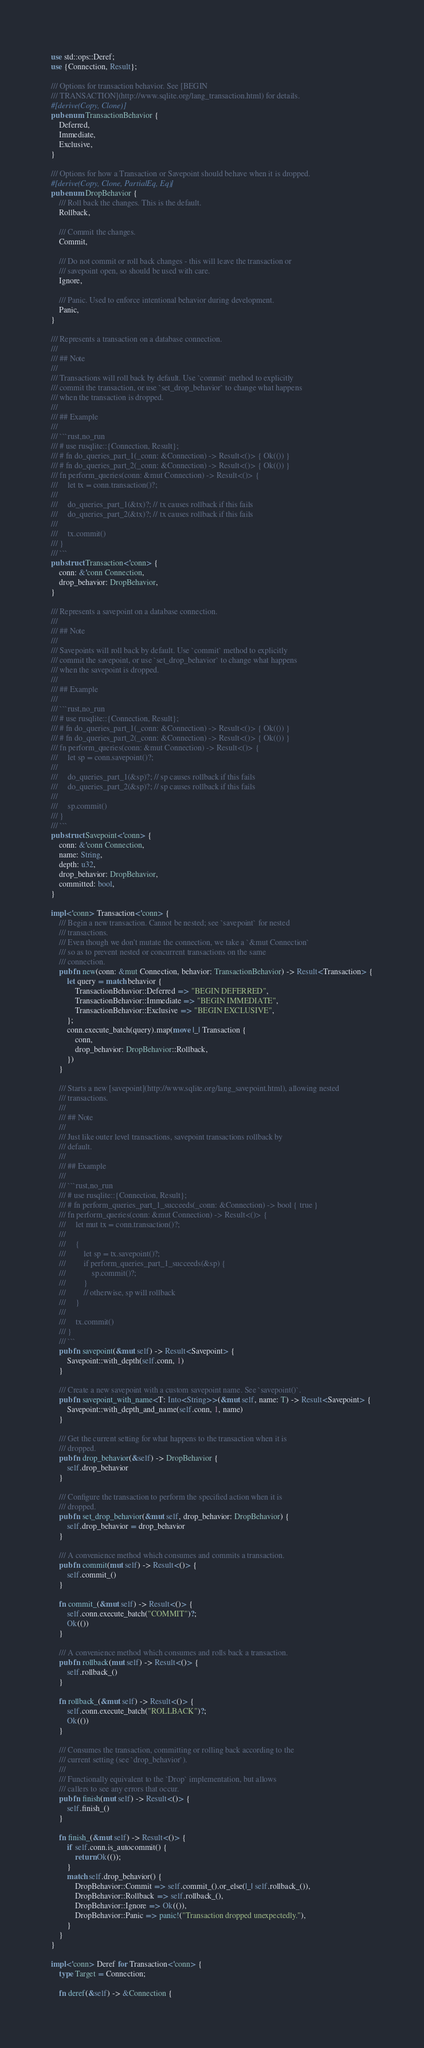Convert code to text. <code><loc_0><loc_0><loc_500><loc_500><_Rust_>use std::ops::Deref;
use {Connection, Result};

/// Options for transaction behavior. See [BEGIN
/// TRANSACTION](http://www.sqlite.org/lang_transaction.html) for details.
#[derive(Copy, Clone)]
pub enum TransactionBehavior {
    Deferred,
    Immediate,
    Exclusive,
}

/// Options for how a Transaction or Savepoint should behave when it is dropped.
#[derive(Copy, Clone, PartialEq, Eq)]
pub enum DropBehavior {
    /// Roll back the changes. This is the default.
    Rollback,

    /// Commit the changes.
    Commit,

    /// Do not commit or roll back changes - this will leave the transaction or
    /// savepoint open, so should be used with care.
    Ignore,

    /// Panic. Used to enforce intentional behavior during development.
    Panic,
}

/// Represents a transaction on a database connection.
///
/// ## Note
///
/// Transactions will roll back by default. Use `commit` method to explicitly
/// commit the transaction, or use `set_drop_behavior` to change what happens
/// when the transaction is dropped.
///
/// ## Example
///
/// ```rust,no_run
/// # use rusqlite::{Connection, Result};
/// # fn do_queries_part_1(_conn: &Connection) -> Result<()> { Ok(()) }
/// # fn do_queries_part_2(_conn: &Connection) -> Result<()> { Ok(()) }
/// fn perform_queries(conn: &mut Connection) -> Result<()> {
///     let tx = conn.transaction()?;
///
///     do_queries_part_1(&tx)?; // tx causes rollback if this fails
///     do_queries_part_2(&tx)?; // tx causes rollback if this fails
///
///     tx.commit()
/// }
/// ```
pub struct Transaction<'conn> {
    conn: &'conn Connection,
    drop_behavior: DropBehavior,
}

/// Represents a savepoint on a database connection.
///
/// ## Note
///
/// Savepoints will roll back by default. Use `commit` method to explicitly
/// commit the savepoint, or use `set_drop_behavior` to change what happens
/// when the savepoint is dropped.
///
/// ## Example
///
/// ```rust,no_run
/// # use rusqlite::{Connection, Result};
/// # fn do_queries_part_1(_conn: &Connection) -> Result<()> { Ok(()) }
/// # fn do_queries_part_2(_conn: &Connection) -> Result<()> { Ok(()) }
/// fn perform_queries(conn: &mut Connection) -> Result<()> {
///     let sp = conn.savepoint()?;
///
///     do_queries_part_1(&sp)?; // sp causes rollback if this fails
///     do_queries_part_2(&sp)?; // sp causes rollback if this fails
///
///     sp.commit()
/// }
/// ```
pub struct Savepoint<'conn> {
    conn: &'conn Connection,
    name: String,
    depth: u32,
    drop_behavior: DropBehavior,
    committed: bool,
}

impl<'conn> Transaction<'conn> {
    /// Begin a new transaction. Cannot be nested; see `savepoint` for nested
    /// transactions.
    /// Even though we don't mutate the connection, we take a `&mut Connection`
    /// so as to prevent nested or concurrent transactions on the same
    /// connection.
    pub fn new(conn: &mut Connection, behavior: TransactionBehavior) -> Result<Transaction> {
        let query = match behavior {
            TransactionBehavior::Deferred => "BEGIN DEFERRED",
            TransactionBehavior::Immediate => "BEGIN IMMEDIATE",
            TransactionBehavior::Exclusive => "BEGIN EXCLUSIVE",
        };
        conn.execute_batch(query).map(move |_| Transaction {
            conn,
            drop_behavior: DropBehavior::Rollback,
        })
    }

    /// Starts a new [savepoint](http://www.sqlite.org/lang_savepoint.html), allowing nested
    /// transactions.
    ///
    /// ## Note
    ///
    /// Just like outer level transactions, savepoint transactions rollback by
    /// default.
    ///
    /// ## Example
    ///
    /// ```rust,no_run
    /// # use rusqlite::{Connection, Result};
    /// # fn perform_queries_part_1_succeeds(_conn: &Connection) -> bool { true }
    /// fn perform_queries(conn: &mut Connection) -> Result<()> {
    ///     let mut tx = conn.transaction()?;
    ///
    ///     {
    ///         let sp = tx.savepoint()?;
    ///         if perform_queries_part_1_succeeds(&sp) {
    ///             sp.commit()?;
    ///         }
    ///         // otherwise, sp will rollback
    ///     }
    ///
    ///     tx.commit()
    /// }
    /// ```
    pub fn savepoint(&mut self) -> Result<Savepoint> {
        Savepoint::with_depth(self.conn, 1)
    }

    /// Create a new savepoint with a custom savepoint name. See `savepoint()`.
    pub fn savepoint_with_name<T: Into<String>>(&mut self, name: T) -> Result<Savepoint> {
        Savepoint::with_depth_and_name(self.conn, 1, name)
    }

    /// Get the current setting for what happens to the transaction when it is
    /// dropped.
    pub fn drop_behavior(&self) -> DropBehavior {
        self.drop_behavior
    }

    /// Configure the transaction to perform the specified action when it is
    /// dropped.
    pub fn set_drop_behavior(&mut self, drop_behavior: DropBehavior) {
        self.drop_behavior = drop_behavior
    }

    /// A convenience method which consumes and commits a transaction.
    pub fn commit(mut self) -> Result<()> {
        self.commit_()
    }

    fn commit_(&mut self) -> Result<()> {
        self.conn.execute_batch("COMMIT")?;
        Ok(())
    }

    /// A convenience method which consumes and rolls back a transaction.
    pub fn rollback(mut self) -> Result<()> {
        self.rollback_()
    }

    fn rollback_(&mut self) -> Result<()> {
        self.conn.execute_batch("ROLLBACK")?;
        Ok(())
    }

    /// Consumes the transaction, committing or rolling back according to the
    /// current setting (see `drop_behavior`).
    ///
    /// Functionally equivalent to the `Drop` implementation, but allows
    /// callers to see any errors that occur.
    pub fn finish(mut self) -> Result<()> {
        self.finish_()
    }

    fn finish_(&mut self) -> Result<()> {
        if self.conn.is_autocommit() {
            return Ok(());
        }
        match self.drop_behavior() {
            DropBehavior::Commit => self.commit_().or_else(|_| self.rollback_()),
            DropBehavior::Rollback => self.rollback_(),
            DropBehavior::Ignore => Ok(()),
            DropBehavior::Panic => panic!("Transaction dropped unexpectedly."),
        }
    }
}

impl<'conn> Deref for Transaction<'conn> {
    type Target = Connection;

    fn deref(&self) -> &Connection {</code> 